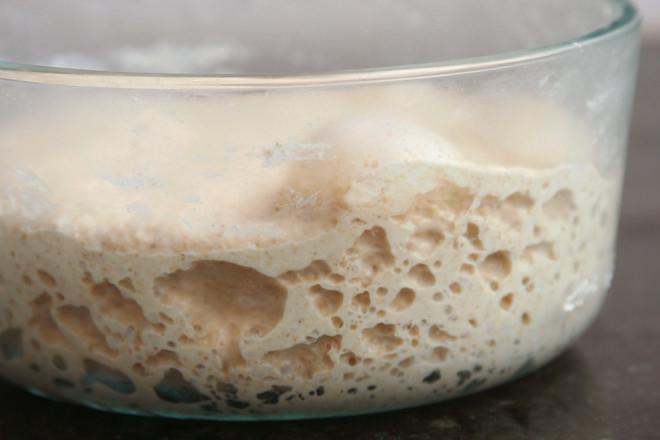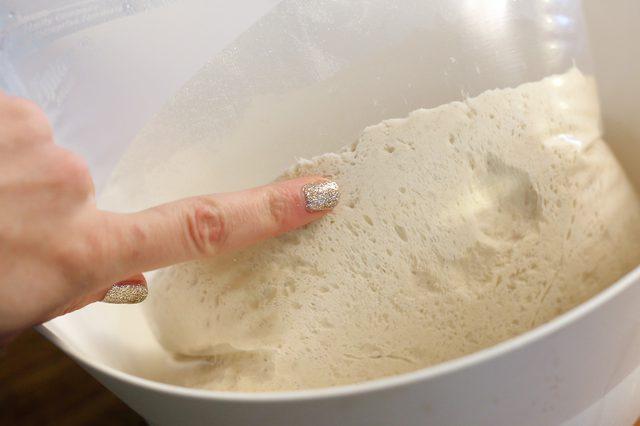The first image is the image on the left, the second image is the image on the right. Given the left and right images, does the statement "Some of the dough is still in the mixing bowl." hold true? Answer yes or no. Yes. 